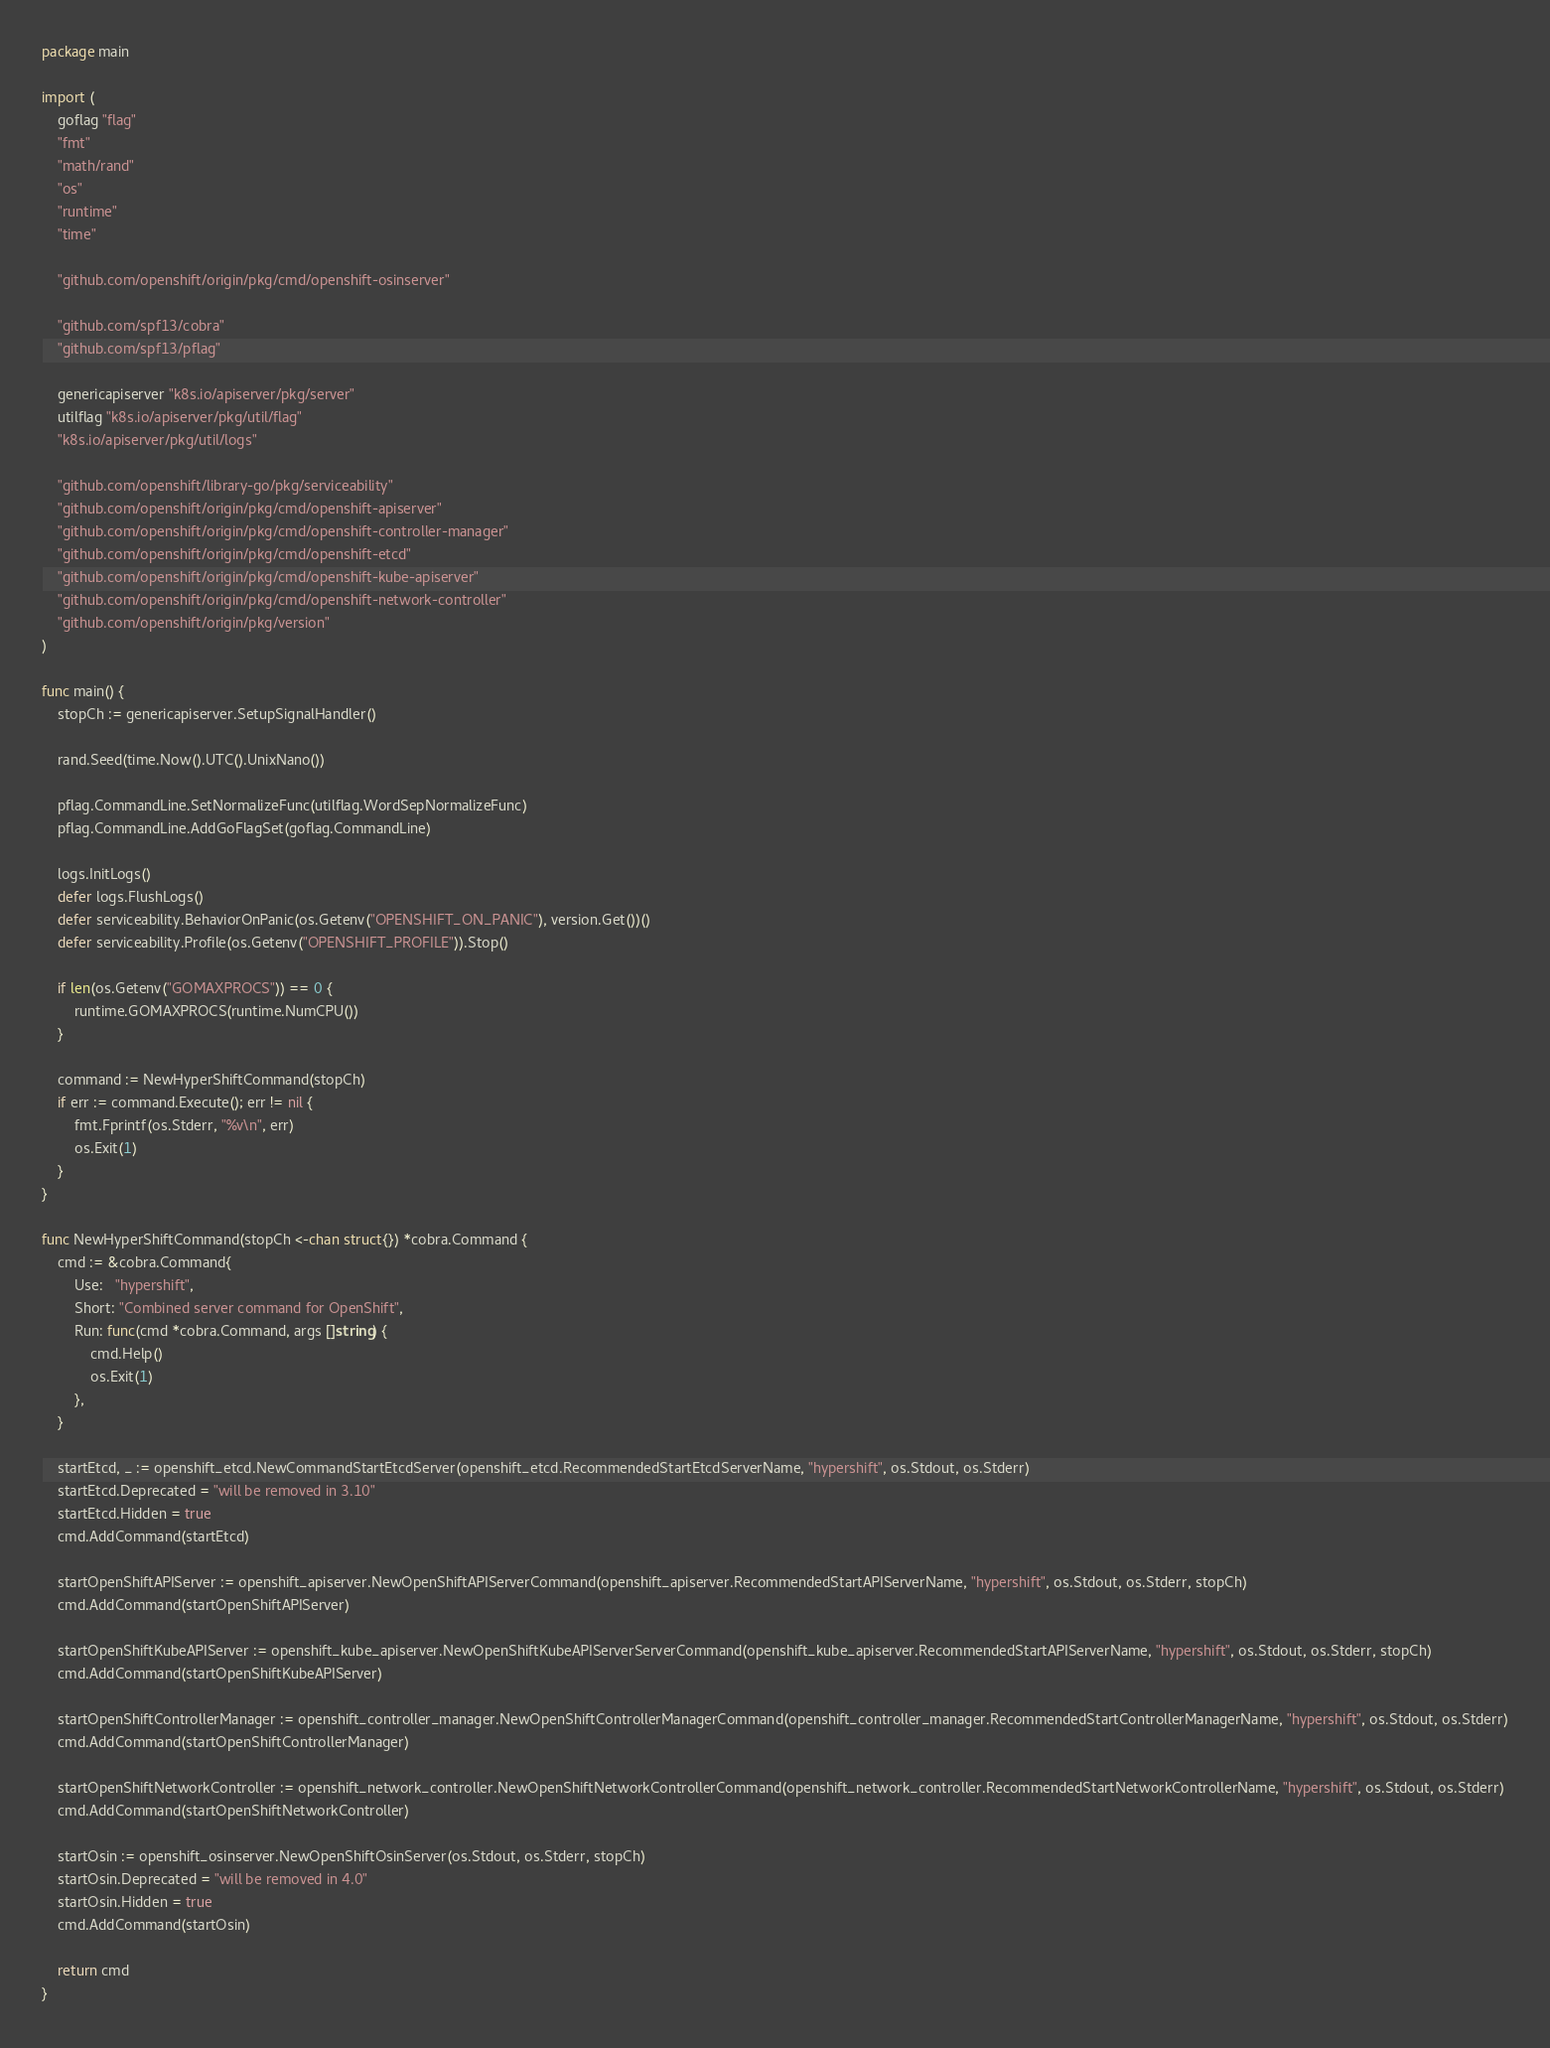Convert code to text. <code><loc_0><loc_0><loc_500><loc_500><_Go_>package main

import (
	goflag "flag"
	"fmt"
	"math/rand"
	"os"
	"runtime"
	"time"

	"github.com/openshift/origin/pkg/cmd/openshift-osinserver"

	"github.com/spf13/cobra"
	"github.com/spf13/pflag"

	genericapiserver "k8s.io/apiserver/pkg/server"
	utilflag "k8s.io/apiserver/pkg/util/flag"
	"k8s.io/apiserver/pkg/util/logs"

	"github.com/openshift/library-go/pkg/serviceability"
	"github.com/openshift/origin/pkg/cmd/openshift-apiserver"
	"github.com/openshift/origin/pkg/cmd/openshift-controller-manager"
	"github.com/openshift/origin/pkg/cmd/openshift-etcd"
	"github.com/openshift/origin/pkg/cmd/openshift-kube-apiserver"
	"github.com/openshift/origin/pkg/cmd/openshift-network-controller"
	"github.com/openshift/origin/pkg/version"
)

func main() {
	stopCh := genericapiserver.SetupSignalHandler()

	rand.Seed(time.Now().UTC().UnixNano())

	pflag.CommandLine.SetNormalizeFunc(utilflag.WordSepNormalizeFunc)
	pflag.CommandLine.AddGoFlagSet(goflag.CommandLine)

	logs.InitLogs()
	defer logs.FlushLogs()
	defer serviceability.BehaviorOnPanic(os.Getenv("OPENSHIFT_ON_PANIC"), version.Get())()
	defer serviceability.Profile(os.Getenv("OPENSHIFT_PROFILE")).Stop()

	if len(os.Getenv("GOMAXPROCS")) == 0 {
		runtime.GOMAXPROCS(runtime.NumCPU())
	}

	command := NewHyperShiftCommand(stopCh)
	if err := command.Execute(); err != nil {
		fmt.Fprintf(os.Stderr, "%v\n", err)
		os.Exit(1)
	}
}

func NewHyperShiftCommand(stopCh <-chan struct{}) *cobra.Command {
	cmd := &cobra.Command{
		Use:   "hypershift",
		Short: "Combined server command for OpenShift",
		Run: func(cmd *cobra.Command, args []string) {
			cmd.Help()
			os.Exit(1)
		},
	}

	startEtcd, _ := openshift_etcd.NewCommandStartEtcdServer(openshift_etcd.RecommendedStartEtcdServerName, "hypershift", os.Stdout, os.Stderr)
	startEtcd.Deprecated = "will be removed in 3.10"
	startEtcd.Hidden = true
	cmd.AddCommand(startEtcd)

	startOpenShiftAPIServer := openshift_apiserver.NewOpenShiftAPIServerCommand(openshift_apiserver.RecommendedStartAPIServerName, "hypershift", os.Stdout, os.Stderr, stopCh)
	cmd.AddCommand(startOpenShiftAPIServer)

	startOpenShiftKubeAPIServer := openshift_kube_apiserver.NewOpenShiftKubeAPIServerServerCommand(openshift_kube_apiserver.RecommendedStartAPIServerName, "hypershift", os.Stdout, os.Stderr, stopCh)
	cmd.AddCommand(startOpenShiftKubeAPIServer)

	startOpenShiftControllerManager := openshift_controller_manager.NewOpenShiftControllerManagerCommand(openshift_controller_manager.RecommendedStartControllerManagerName, "hypershift", os.Stdout, os.Stderr)
	cmd.AddCommand(startOpenShiftControllerManager)

	startOpenShiftNetworkController := openshift_network_controller.NewOpenShiftNetworkControllerCommand(openshift_network_controller.RecommendedStartNetworkControllerName, "hypershift", os.Stdout, os.Stderr)
	cmd.AddCommand(startOpenShiftNetworkController)

	startOsin := openshift_osinserver.NewOpenShiftOsinServer(os.Stdout, os.Stderr, stopCh)
	startOsin.Deprecated = "will be removed in 4.0"
	startOsin.Hidden = true
	cmd.AddCommand(startOsin)

	return cmd
}
</code> 